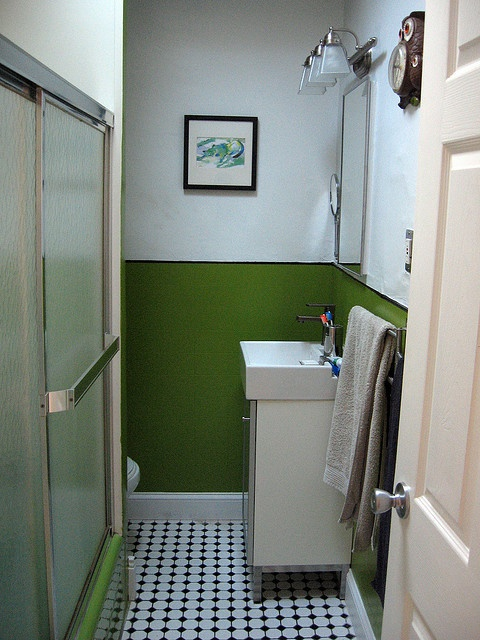Describe the objects in this image and their specific colors. I can see sink in gray and lightblue tones, toilet in gray tones, clock in gray, darkgray, and lightgray tones, toothbrush in gray, red, salmon, and black tones, and toothbrush in gray, blue, and black tones in this image. 